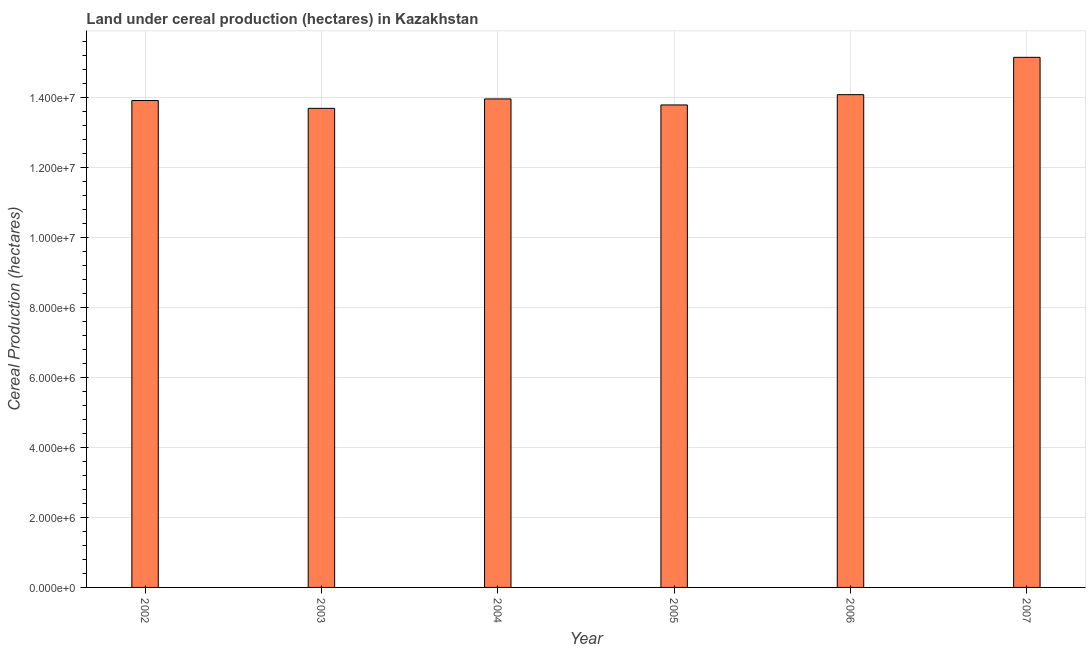Does the graph contain any zero values?
Your answer should be very brief. No. Does the graph contain grids?
Keep it short and to the point. Yes. What is the title of the graph?
Your answer should be very brief. Land under cereal production (hectares) in Kazakhstan. What is the label or title of the X-axis?
Give a very brief answer. Year. What is the label or title of the Y-axis?
Make the answer very short. Cereal Production (hectares). What is the land under cereal production in 2004?
Give a very brief answer. 1.39e+07. Across all years, what is the maximum land under cereal production?
Offer a terse response. 1.51e+07. Across all years, what is the minimum land under cereal production?
Provide a succinct answer. 1.37e+07. In which year was the land under cereal production minimum?
Make the answer very short. 2003. What is the sum of the land under cereal production?
Make the answer very short. 8.45e+07. What is the difference between the land under cereal production in 2002 and 2005?
Offer a terse response. 1.26e+05. What is the average land under cereal production per year?
Your answer should be compact. 1.41e+07. What is the median land under cereal production?
Your answer should be very brief. 1.39e+07. In how many years, is the land under cereal production greater than 14000000 hectares?
Offer a terse response. 2. Is the difference between the land under cereal production in 2004 and 2005 greater than the difference between any two years?
Your response must be concise. No. What is the difference between the highest and the second highest land under cereal production?
Make the answer very short. 1.07e+06. Is the sum of the land under cereal production in 2006 and 2007 greater than the maximum land under cereal production across all years?
Offer a terse response. Yes. What is the difference between the highest and the lowest land under cereal production?
Your answer should be compact. 1.46e+06. How many bars are there?
Ensure brevity in your answer.  6. Are all the bars in the graph horizontal?
Your response must be concise. No. Are the values on the major ticks of Y-axis written in scientific E-notation?
Your answer should be compact. Yes. What is the Cereal Production (hectares) in 2002?
Your answer should be very brief. 1.39e+07. What is the Cereal Production (hectares) of 2003?
Provide a succinct answer. 1.37e+07. What is the Cereal Production (hectares) of 2004?
Provide a short and direct response. 1.39e+07. What is the Cereal Production (hectares) of 2005?
Your answer should be compact. 1.38e+07. What is the Cereal Production (hectares) of 2006?
Your answer should be very brief. 1.41e+07. What is the Cereal Production (hectares) in 2007?
Provide a succinct answer. 1.51e+07. What is the difference between the Cereal Production (hectares) in 2002 and 2003?
Ensure brevity in your answer.  2.23e+05. What is the difference between the Cereal Production (hectares) in 2002 and 2004?
Your response must be concise. -4.63e+04. What is the difference between the Cereal Production (hectares) in 2002 and 2005?
Offer a terse response. 1.26e+05. What is the difference between the Cereal Production (hectares) in 2002 and 2006?
Offer a terse response. -1.68e+05. What is the difference between the Cereal Production (hectares) in 2002 and 2007?
Provide a succinct answer. -1.23e+06. What is the difference between the Cereal Production (hectares) in 2003 and 2004?
Offer a terse response. -2.70e+05. What is the difference between the Cereal Production (hectares) in 2003 and 2005?
Offer a terse response. -9.73e+04. What is the difference between the Cereal Production (hectares) in 2003 and 2006?
Your answer should be compact. -3.91e+05. What is the difference between the Cereal Production (hectares) in 2003 and 2007?
Ensure brevity in your answer.  -1.46e+06. What is the difference between the Cereal Production (hectares) in 2004 and 2005?
Provide a succinct answer. 1.72e+05. What is the difference between the Cereal Production (hectares) in 2004 and 2006?
Provide a short and direct response. -1.21e+05. What is the difference between the Cereal Production (hectares) in 2004 and 2007?
Make the answer very short. -1.19e+06. What is the difference between the Cereal Production (hectares) in 2005 and 2006?
Offer a terse response. -2.93e+05. What is the difference between the Cereal Production (hectares) in 2005 and 2007?
Your answer should be very brief. -1.36e+06. What is the difference between the Cereal Production (hectares) in 2006 and 2007?
Provide a succinct answer. -1.07e+06. What is the ratio of the Cereal Production (hectares) in 2002 to that in 2005?
Provide a succinct answer. 1.01. What is the ratio of the Cereal Production (hectares) in 2002 to that in 2006?
Provide a succinct answer. 0.99. What is the ratio of the Cereal Production (hectares) in 2002 to that in 2007?
Give a very brief answer. 0.92. What is the ratio of the Cereal Production (hectares) in 2003 to that in 2004?
Provide a short and direct response. 0.98. What is the ratio of the Cereal Production (hectares) in 2003 to that in 2005?
Give a very brief answer. 0.99. What is the ratio of the Cereal Production (hectares) in 2003 to that in 2007?
Your response must be concise. 0.9. What is the ratio of the Cereal Production (hectares) in 2004 to that in 2005?
Provide a succinct answer. 1.01. What is the ratio of the Cereal Production (hectares) in 2004 to that in 2007?
Provide a succinct answer. 0.92. What is the ratio of the Cereal Production (hectares) in 2005 to that in 2006?
Provide a succinct answer. 0.98. What is the ratio of the Cereal Production (hectares) in 2005 to that in 2007?
Your response must be concise. 0.91. 